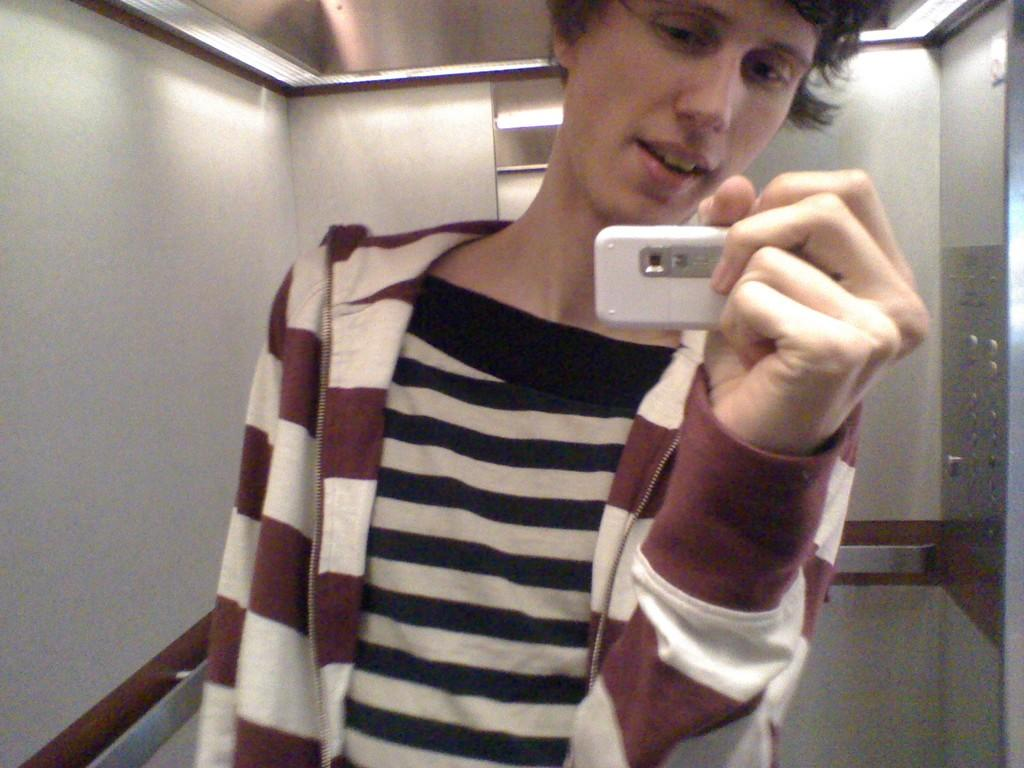What is the main subject of the image? The main subject of the image is a person standing. What is the person holding in his hand? The person is holding a white phone in his hand. What type of brick is the person using to make a call in the image? There is no brick present in the image, and the person is using a white phone to make a call. How many quarters can be seen in the person's hand in the image? There are no quarters present in the image; the person is holding a white phone. 